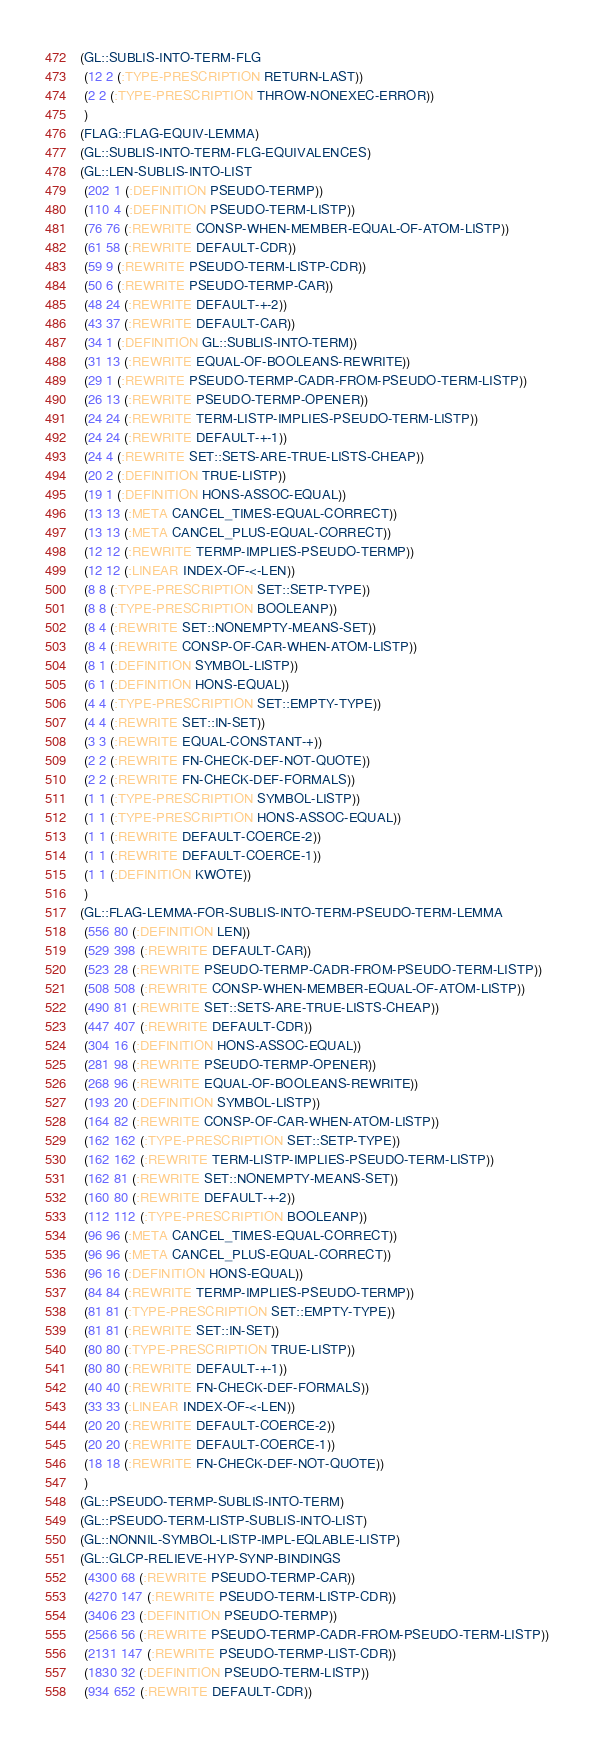<code> <loc_0><loc_0><loc_500><loc_500><_Lisp_>(GL::SUBLIS-INTO-TERM-FLG
 (12 2 (:TYPE-PRESCRIPTION RETURN-LAST))
 (2 2 (:TYPE-PRESCRIPTION THROW-NONEXEC-ERROR))
 )
(FLAG::FLAG-EQUIV-LEMMA)
(GL::SUBLIS-INTO-TERM-FLG-EQUIVALENCES)
(GL::LEN-SUBLIS-INTO-LIST
 (202 1 (:DEFINITION PSEUDO-TERMP))
 (110 4 (:DEFINITION PSEUDO-TERM-LISTP))
 (76 76 (:REWRITE CONSP-WHEN-MEMBER-EQUAL-OF-ATOM-LISTP))
 (61 58 (:REWRITE DEFAULT-CDR))
 (59 9 (:REWRITE PSEUDO-TERM-LISTP-CDR))
 (50 6 (:REWRITE PSEUDO-TERMP-CAR))
 (48 24 (:REWRITE DEFAULT-+-2))
 (43 37 (:REWRITE DEFAULT-CAR))
 (34 1 (:DEFINITION GL::SUBLIS-INTO-TERM))
 (31 13 (:REWRITE EQUAL-OF-BOOLEANS-REWRITE))
 (29 1 (:REWRITE PSEUDO-TERMP-CADR-FROM-PSEUDO-TERM-LISTP))
 (26 13 (:REWRITE PSEUDO-TERMP-OPENER))
 (24 24 (:REWRITE TERM-LISTP-IMPLIES-PSEUDO-TERM-LISTP))
 (24 24 (:REWRITE DEFAULT-+-1))
 (24 4 (:REWRITE SET::SETS-ARE-TRUE-LISTS-CHEAP))
 (20 2 (:DEFINITION TRUE-LISTP))
 (19 1 (:DEFINITION HONS-ASSOC-EQUAL))
 (13 13 (:META CANCEL_TIMES-EQUAL-CORRECT))
 (13 13 (:META CANCEL_PLUS-EQUAL-CORRECT))
 (12 12 (:REWRITE TERMP-IMPLIES-PSEUDO-TERMP))
 (12 12 (:LINEAR INDEX-OF-<-LEN))
 (8 8 (:TYPE-PRESCRIPTION SET::SETP-TYPE))
 (8 8 (:TYPE-PRESCRIPTION BOOLEANP))
 (8 4 (:REWRITE SET::NONEMPTY-MEANS-SET))
 (8 4 (:REWRITE CONSP-OF-CAR-WHEN-ATOM-LISTP))
 (8 1 (:DEFINITION SYMBOL-LISTP))
 (6 1 (:DEFINITION HONS-EQUAL))
 (4 4 (:TYPE-PRESCRIPTION SET::EMPTY-TYPE))
 (4 4 (:REWRITE SET::IN-SET))
 (3 3 (:REWRITE EQUAL-CONSTANT-+))
 (2 2 (:REWRITE FN-CHECK-DEF-NOT-QUOTE))
 (2 2 (:REWRITE FN-CHECK-DEF-FORMALS))
 (1 1 (:TYPE-PRESCRIPTION SYMBOL-LISTP))
 (1 1 (:TYPE-PRESCRIPTION HONS-ASSOC-EQUAL))
 (1 1 (:REWRITE DEFAULT-COERCE-2))
 (1 1 (:REWRITE DEFAULT-COERCE-1))
 (1 1 (:DEFINITION KWOTE))
 )
(GL::FLAG-LEMMA-FOR-SUBLIS-INTO-TERM-PSEUDO-TERM-LEMMA
 (556 80 (:DEFINITION LEN))
 (529 398 (:REWRITE DEFAULT-CAR))
 (523 28 (:REWRITE PSEUDO-TERMP-CADR-FROM-PSEUDO-TERM-LISTP))
 (508 508 (:REWRITE CONSP-WHEN-MEMBER-EQUAL-OF-ATOM-LISTP))
 (490 81 (:REWRITE SET::SETS-ARE-TRUE-LISTS-CHEAP))
 (447 407 (:REWRITE DEFAULT-CDR))
 (304 16 (:DEFINITION HONS-ASSOC-EQUAL))
 (281 98 (:REWRITE PSEUDO-TERMP-OPENER))
 (268 96 (:REWRITE EQUAL-OF-BOOLEANS-REWRITE))
 (193 20 (:DEFINITION SYMBOL-LISTP))
 (164 82 (:REWRITE CONSP-OF-CAR-WHEN-ATOM-LISTP))
 (162 162 (:TYPE-PRESCRIPTION SET::SETP-TYPE))
 (162 162 (:REWRITE TERM-LISTP-IMPLIES-PSEUDO-TERM-LISTP))
 (162 81 (:REWRITE SET::NONEMPTY-MEANS-SET))
 (160 80 (:REWRITE DEFAULT-+-2))
 (112 112 (:TYPE-PRESCRIPTION BOOLEANP))
 (96 96 (:META CANCEL_TIMES-EQUAL-CORRECT))
 (96 96 (:META CANCEL_PLUS-EQUAL-CORRECT))
 (96 16 (:DEFINITION HONS-EQUAL))
 (84 84 (:REWRITE TERMP-IMPLIES-PSEUDO-TERMP))
 (81 81 (:TYPE-PRESCRIPTION SET::EMPTY-TYPE))
 (81 81 (:REWRITE SET::IN-SET))
 (80 80 (:TYPE-PRESCRIPTION TRUE-LISTP))
 (80 80 (:REWRITE DEFAULT-+-1))
 (40 40 (:REWRITE FN-CHECK-DEF-FORMALS))
 (33 33 (:LINEAR INDEX-OF-<-LEN))
 (20 20 (:REWRITE DEFAULT-COERCE-2))
 (20 20 (:REWRITE DEFAULT-COERCE-1))
 (18 18 (:REWRITE FN-CHECK-DEF-NOT-QUOTE))
 )
(GL::PSEUDO-TERMP-SUBLIS-INTO-TERM)
(GL::PSEUDO-TERM-LISTP-SUBLIS-INTO-LIST)
(GL::NONNIL-SYMBOL-LISTP-IMPL-EQLABLE-LISTP)
(GL::GLCP-RELIEVE-HYP-SYNP-BINDINGS
 (4300 68 (:REWRITE PSEUDO-TERMP-CAR))
 (4270 147 (:REWRITE PSEUDO-TERM-LISTP-CDR))
 (3406 23 (:DEFINITION PSEUDO-TERMP))
 (2566 56 (:REWRITE PSEUDO-TERMP-CADR-FROM-PSEUDO-TERM-LISTP))
 (2131 147 (:REWRITE PSEUDO-TERMP-LIST-CDR))
 (1830 32 (:DEFINITION PSEUDO-TERM-LISTP))
 (934 652 (:REWRITE DEFAULT-CDR))</code> 